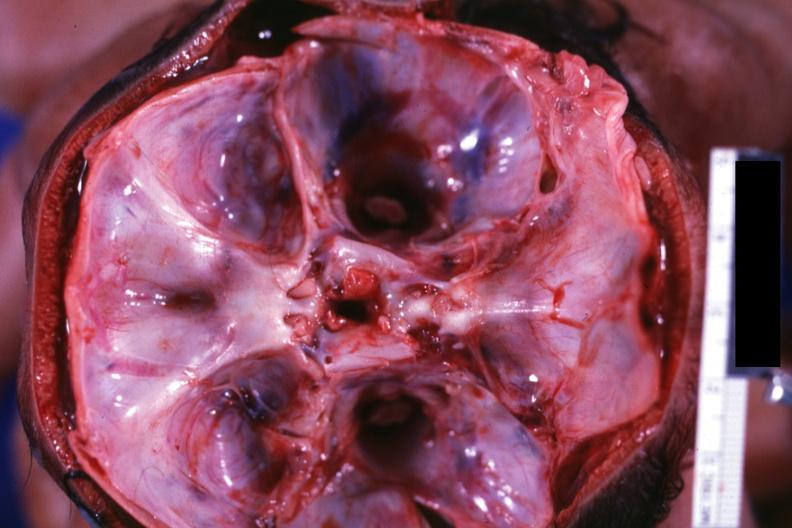does this image show opened skull showing base with two foramina magna?
Answer the question using a single word or phrase. Yes 